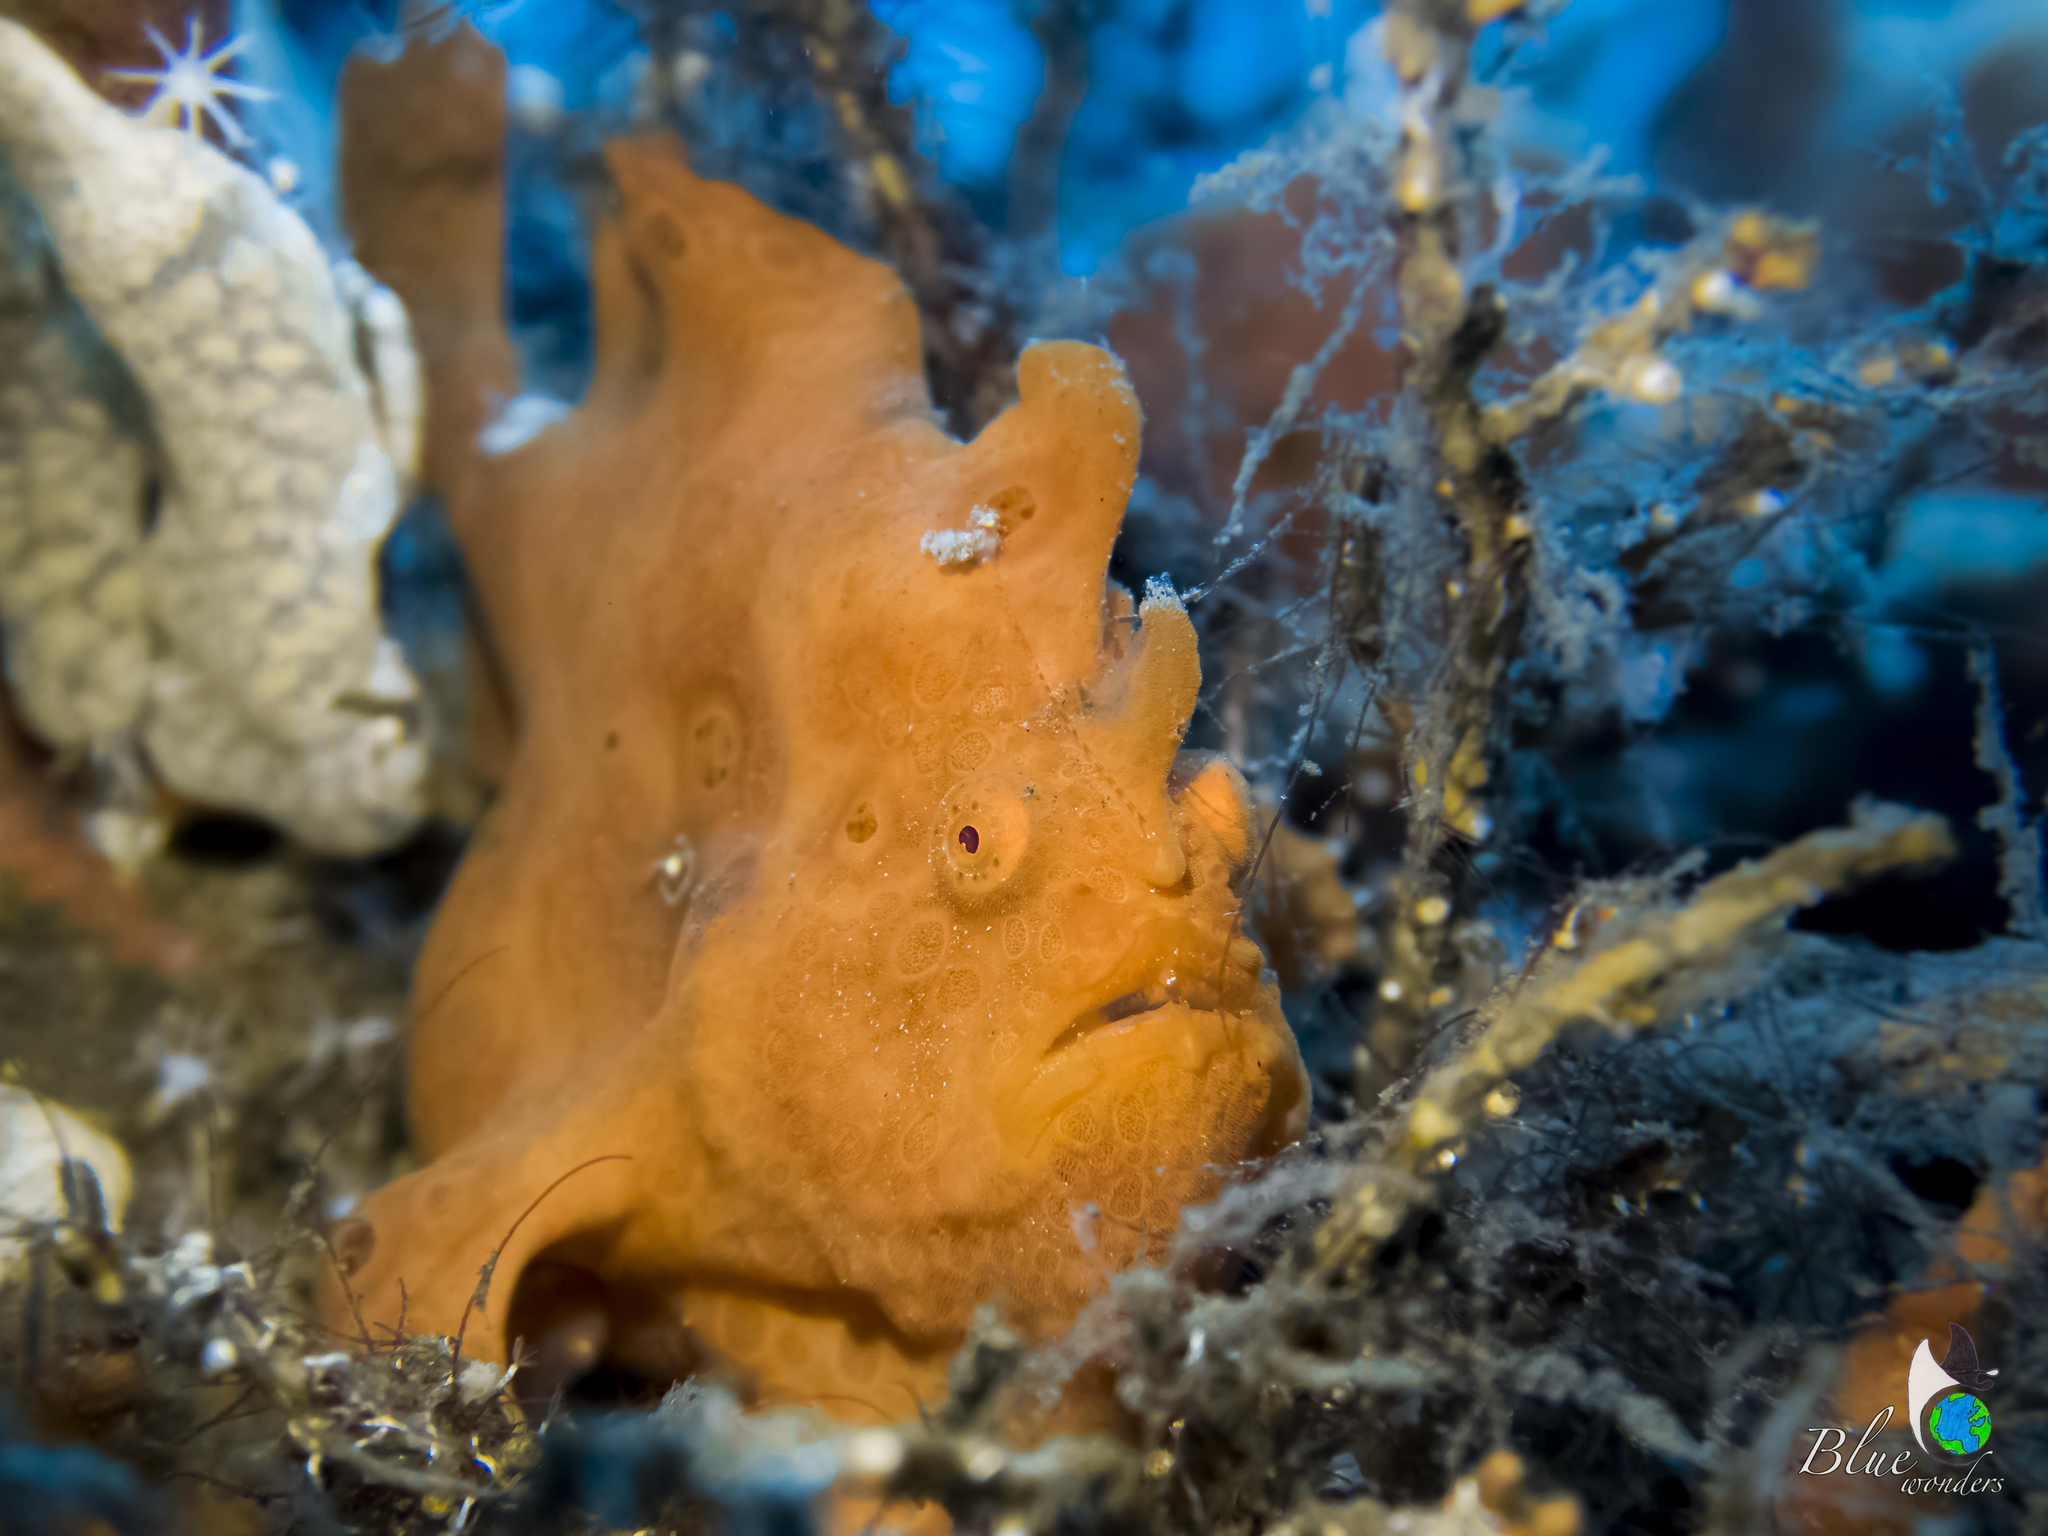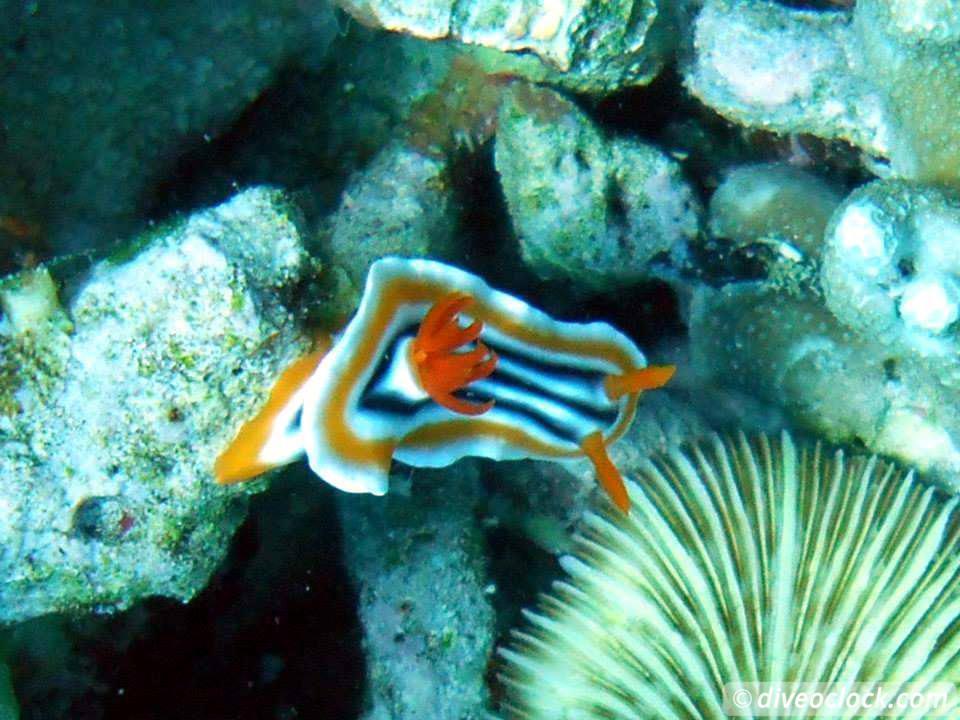The first image is the image on the left, the second image is the image on the right. For the images displayed, is the sentence "The right image contains some creature with black and white stripes and with two antenna-type horns and something flower-like sprouting from its back." factually correct? Answer yes or no. Yes. 